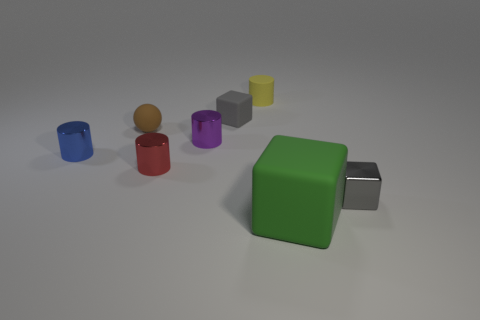What material is the small block behind the blue cylinder?
Offer a very short reply. Rubber. What is the size of the gray thing that is behind the small gray thing that is in front of the sphere?
Give a very brief answer. Small. Are there any yellow things made of the same material as the blue cylinder?
Keep it short and to the point. No. What shape is the matte object in front of the small gray thing that is to the right of the small gray object that is behind the matte sphere?
Your answer should be compact. Cube. Do the rubber block behind the green rubber thing and the small cylinder to the right of the tiny gray matte thing have the same color?
Your response must be concise. No. Is there anything else that is the same size as the purple metallic thing?
Make the answer very short. Yes. Are there any small gray metal cubes behind the small yellow thing?
Ensure brevity in your answer.  No. What number of tiny gray matte things have the same shape as the tiny red shiny thing?
Ensure brevity in your answer.  0. There is a small matte thing in front of the rubber block that is behind the small gray thing that is in front of the small ball; what color is it?
Make the answer very short. Brown. Is the material of the gray object right of the big green block the same as the tiny cylinder behind the small purple cylinder?
Provide a short and direct response. No. 